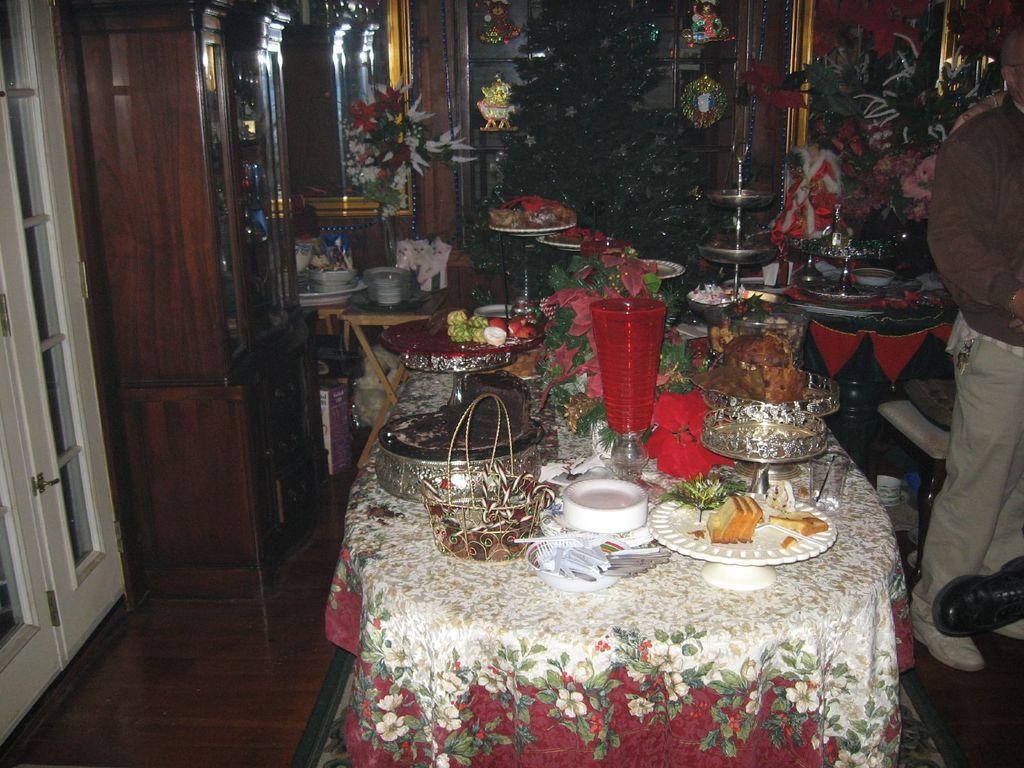How would you summarize this image in a sentence or two? In this image we can see a table covered with a cloth and there is a plate with food items, a basket and few object on the table and there is a cupboard, a tree and few objects in a room, there is a door on the left side and a person standing on the right side. 